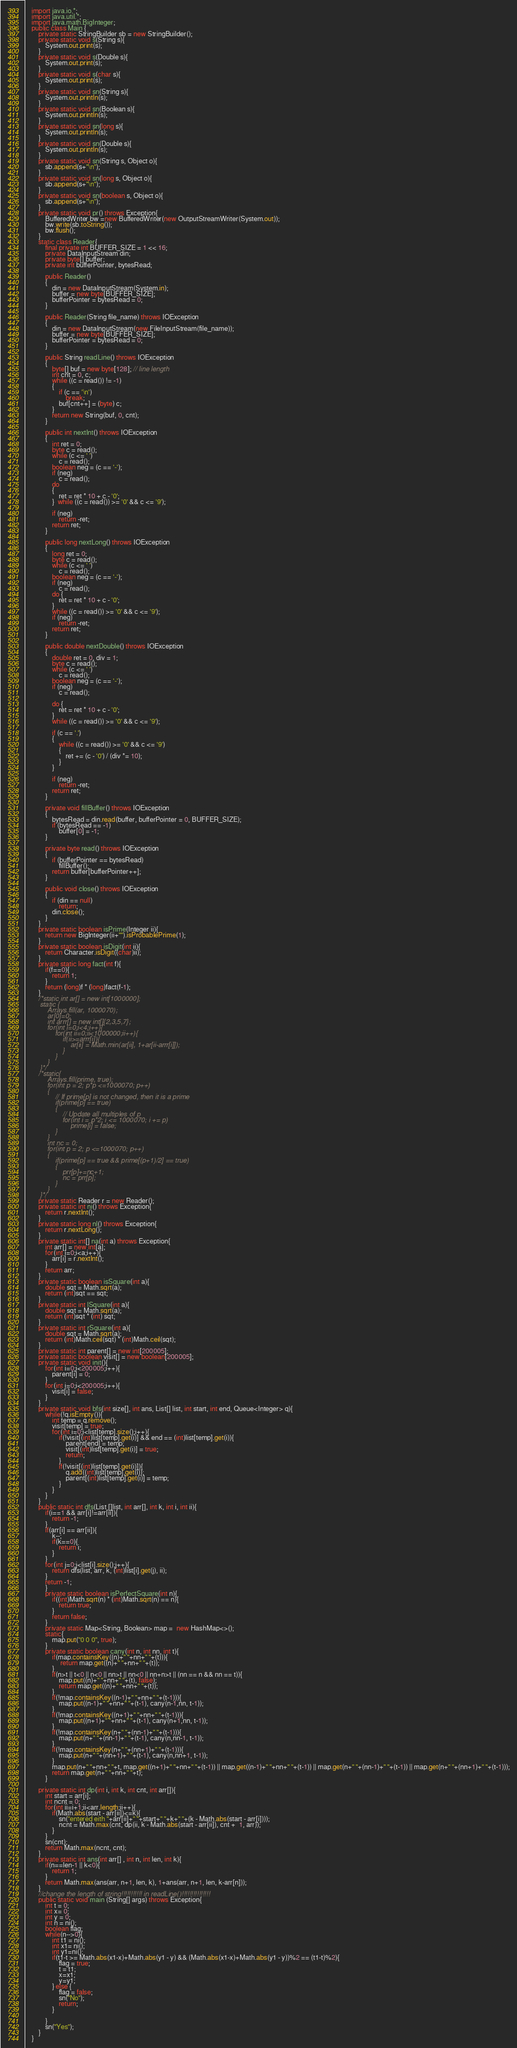<code> <loc_0><loc_0><loc_500><loc_500><_Java_>    import java.io.*;
    import java.util.*;
    import java.math.BigInteger;
    public class Main {
        private static StringBuilder sb = new StringBuilder();
        private static void s(String s){
            System.out.print(s);
        }
        private static void s(Double s){
            System.out.print(s);
        }
        private static void s(char s){
            System.out.print(s);
        }
        private static void sn(String s){
            System.out.println(s);
        }
        private static void sn(Boolean s){
            System.out.println(s);
        }
        private static void sn(long s){
            System.out.println(s);
        }
        private static void sn(Double s){
            System.out.println(s);
        }
        private static void sn(String s, Object o){
            sb.append(s+"\n");
        }
        private static void sn(long s, Object o){
            sb.append(s+"\n");
        }
        private static void sn(boolean s, Object o){
            sb.append(s+"\n");
        }
        private static void pr() throws Exception{
            BufferedWriter bw =new BufferedWriter(new OutputStreamWriter(System.out));
            bw.write(sb.toString());
            bw.flush();
        }
        static class Reader{
            final private int BUFFER_SIZE = 1 << 16;
            private DataInputStream din;
            private byte[] buffer;
            private int bufferPointer, bytesRead;
     
            public Reader()
            {
                din = new DataInputStream(System.in);
                buffer = new byte[BUFFER_SIZE];
                bufferPointer = bytesRead = 0;
            }
     
            public Reader(String file_name) throws IOException
            {
                din = new DataInputStream(new FileInputStream(file_name));
                buffer = new byte[BUFFER_SIZE];
                bufferPointer = bytesRead = 0;
            }
     
            public String readLine() throws IOException
            {
                byte[] buf = new byte[128]; // line length
                int cnt = 0, c;
                while ((c = read()) != -1)
                {
                    if (c == '\n')
                        break;
                    buf[cnt++] = (byte) c;
                }
                return new String(buf, 0, cnt);
            }
     
            public int nextInt() throws IOException
            {
                int ret = 0;
                byte c = read();
                while (c <= ' ')
                    c = read();
                boolean neg = (c == '-');
                if (neg)
                    c = read();
                do
                {
                    ret = ret * 10 + c - '0';
                }  while ((c = read()) >= '0' && c <= '9');
     
                if (neg)
                    return -ret;
                return ret;
            }
     
            public long nextLong() throws IOException
            {
                long ret = 0;
                byte c = read();
                while (c <= ' ')
                    c = read();
                boolean neg = (c == '-');
                if (neg)
                    c = read();
                do {
                    ret = ret * 10 + c - '0';
                }
                while ((c = read()) >= '0' && c <= '9');
                if (neg)
                    return -ret;
                return ret;
            }
     
            public double nextDouble() throws IOException
            {
                double ret = 0, div = 1;
                byte c = read();
                while (c <= ' ')
                    c = read();
                boolean neg = (c == '-');
                if (neg)
                    c = read();
     
                do {
                    ret = ret * 10 + c - '0';
                }
                while ((c = read()) >= '0' && c <= '9');
     
                if (c == '.')
                {
                    while ((c = read()) >= '0' && c <= '9')
                    {
                        ret += (c - '0') / (div *= 10);
                    }
                }
     
                if (neg)
                    return -ret;
                return ret;
            }
     
            private void fillBuffer() throws IOException
            {
                bytesRead = din.read(buffer, bufferPointer = 0, BUFFER_SIZE);
                if (bytesRead == -1)
                    buffer[0] = -1;
            }
     
            private byte read() throws IOException
            {
                if (bufferPointer == bytesRead)
                    fillBuffer();
                return buffer[bufferPointer++];
            }
     
            public void close() throws IOException
            {
                if (din == null)
                    return;
                din.close();
            }
        }
        private static boolean isPrime(Integer ii){
            return new BigInteger(ii+"").isProbablePrime(1);
        }
        private static boolean isDigit(int ii){
            return Character.isDigit((char)ii);
        }
        private static long fact(int f){
            if(f==0){
                return 1;
            }
            return (long)f * (long)fact(f-1);
        }
        /*static int ar[] = new int[1000000];
        static {
            Arrays.fill(ar, 1000070);
            ar[0]=0;
            int arrr[] = new int[]{2,3,5,7};
            for(int i=0;i<4;i++){
                for(int ii=0;ii<1000000;ii++){
                    if(ii>=arrr[i]){
                        ar[ii] = Math.min(ar[ii], 1+ar[ii-arrr[i]]);
                    }
                }
            }
        }*/
        /*static{
            Arrays.fill(prime, true);
            for(int p = 2; p*p <=1000070; p++)
            {
                // If prime[p] is not changed, then it is a prime
                if(prime[p] == true)
                {
                    // Update all multiples of p
                    for(int i = p*2; i <= 1000070; i += p)
                        prime[i] = false;
                }
            }
            int nc = 0;
            for(int p = 2; p <=1000070; p++)
            {
                if(prime[p] == true && prime[(p+1)/2] == true)
                {
                    prr[p]+=nc+1;
                    nc = prr[p];
                }
            }
        }*/
        private static Reader r = new Reader();
        private static int ni() throws Exception{
            return r.nextInt();
        }
        private static long nl() throws Exception{
            return r.nextLong();
        }
        private static int[] na(int a) throws Exception{
            int arr[] = new int[a];
            for(int i=0;i<a;i++){
                arr[i] = r.nextInt();
            }
            return arr;
        }
        private static boolean isSquare(int a){
            double sqt = Math.sqrt(a);
            return (int)sqt == sqt;
        }
        private static int lSquare(int a){
            double sqt = Math.sqrt(a);
            return (int)sqt * (int) sqt;
        }
        private static int rSquare(int a){
            double sqt = Math.sqrt(a);
            return (int)Math.ceil(sqt) * (int)Math.ceil(sqt);
        }
        private static int parent[] = new int[200005];
        private static boolean visit[] = new boolean[200005];
        private static void init(){
        	for(int i=0;i<200005;i++){
        		parent[i] = 0;
        	}
        	for(int i=0;i<200005;i++){
        		visit[i] = false;
        	}
        }
    	private static void bfs(int size[], int ans, List[] list, int start, int end, Queue<Integer> q){
        	while(!q.isEmpty()){
        		int temp = q.remove();
        		visit[temp] = true;
        		for(int i=0;i<list[temp].size();i++){
        			if(!visit[(int)list[temp].get(i)] && end == (int)list[temp].get(i)){
        				parent[end] = temp;
        				visit[(int)list[temp].get(i)] = true;
        				return;
        			}
        			if(!visit[(int)list[temp].get(i)]){
        				q.add((int)list[temp].get(i));
        				parent[(int)list[temp].get(i)] = temp;
        			}
        		}
        	}
        }
        public static int dfs(List []list, int arr[], int k, int i, int ii){
            if(i==1 && arr[i]!=arr[ii]){
                return -1;
            }
            if(arr[i] == arr[ii]){
                k--;
                if(k==0){
                    return i;
                }
            }
            for(int j=0;j<list[i].size();j++){
                return dfs(list, arr, k, (int)list[i].get(j), ii);
            }
            return -1;
            }
            private static boolean isPerfectSquare(int n){
                if((int)Math.sqrt(n) * (int)Math.sqrt(n) == n){
                    return true;
                }
                return false;
            }
            private static Map<String, Boolean> map =  new HashMap<>();
            static{
                map.put("0 0 0", true);
            }
            private static boolean cany(int n, int nn, int t){
                if(map.containsKey((n)+" "+nn+" "+(t))){
                     return map.get((n)+" "+nn+" "+(t));
                }
                if(n>t || t<0 || n<0 || nn>t || nn<0 || nn+n>t || (nn == n && nn == t)){
                    map.put((n)+" "+nn+" "+(t), false);
                    return map.get((n)+" "+nn+" "+(t));
                }
                if(!map.containsKey((n-1)+" "+nn+" "+(t-1))){
                    map.put((n-1)+" "+nn+" "+(t-1), cany(n-1,nn, t-1));
                }
                if(!map.containsKey((n+1)+" "+nn+" "+(t-1))){
                    map.put((n+1)+" "+nn+" "+(t-1), cany(n+1,nn, t-1));
                }
                if(!map.containsKey(n+" "+(nn-1)+" "+(t-1))){
                    map.put(n+" "+(nn-1)+" "+(t-1), cany(n,nn-1, t-1));
                }
                if(!map.containsKey(n+" "+(nn+1)+" "+(t-1))){
                    map.put(n+" "+(nn+1)+" "+(t-1), cany(n,nn+1, t-1));
                }
                map.put(n+" "+nn+" "+t, map.get((n+1)+" "+nn+" "+(t-1)) || map.get((n-1)+" "+nn+" "+(t-1)) || map.get(n+" "+(nn-1)+" "+(t-1)) || map.get(n+" "+(nn+1)+" "+(t-1)));
                return map.get(n+" "+nn+" "+t);
            }
            
        private static int dp(int i, int k, int cnt, int arr[]){
            int start = arr[i];
            int ncnt = 0;
    	    for(int ii=i+1;ii<arr.length;ii++){
    	        if(Math.abs(start - arr[ii])<=k){
    	            sn("entered eith "+arr[ii]+" "+start+" "+k+" "+(k - Math.abs(start - arr[i])));
    	            ncnt = Math.max(cnt, dp(ii, k - Math.abs(start - arr[ii]), cnt +  1, arr));
    	        }
    	    }
    	    sn(cnt);
    	    return Math.max(ncnt, cnt);
        }
        private static int ans(int arr[] , int n, int len, int k){
            if(n==len-1 || k<0){
                return 1;
            }
            return Math.max(ans(arr, n+1, len, k), 1+ans(arr, n+1, len, k-arr[n]));
        }
        //change the length of string!!!!!!!!!!! in readLine()!!!!!!!!!!!!!!!
    	public static void main (String[] args) throws Exception{
    	    int t = 0;
    	    int x= 0;
    	    int y = 0;
    	    int n = ni();
    	    boolean flag;
    	    while(n-->0){
    	        int t1 = ni();
    	        int x1= ni();
    	        int y1=ni();
    	        if(t1-t >= Math.abs(x1-x)+Math.abs(y1 - y) && (Math.abs(x1-x)+Math.abs(y1 - y))%2 == (t1-t)%2){
    	            flag = true;
    	            t = t1;
    	            x=x1;
    	            y=y1;
    	        } else {
    	            flag = false;
    	            sn("No");
    	            return;
    	        }
    	        
    	    }
    	    sn("Yes");
    	}
    }</code> 